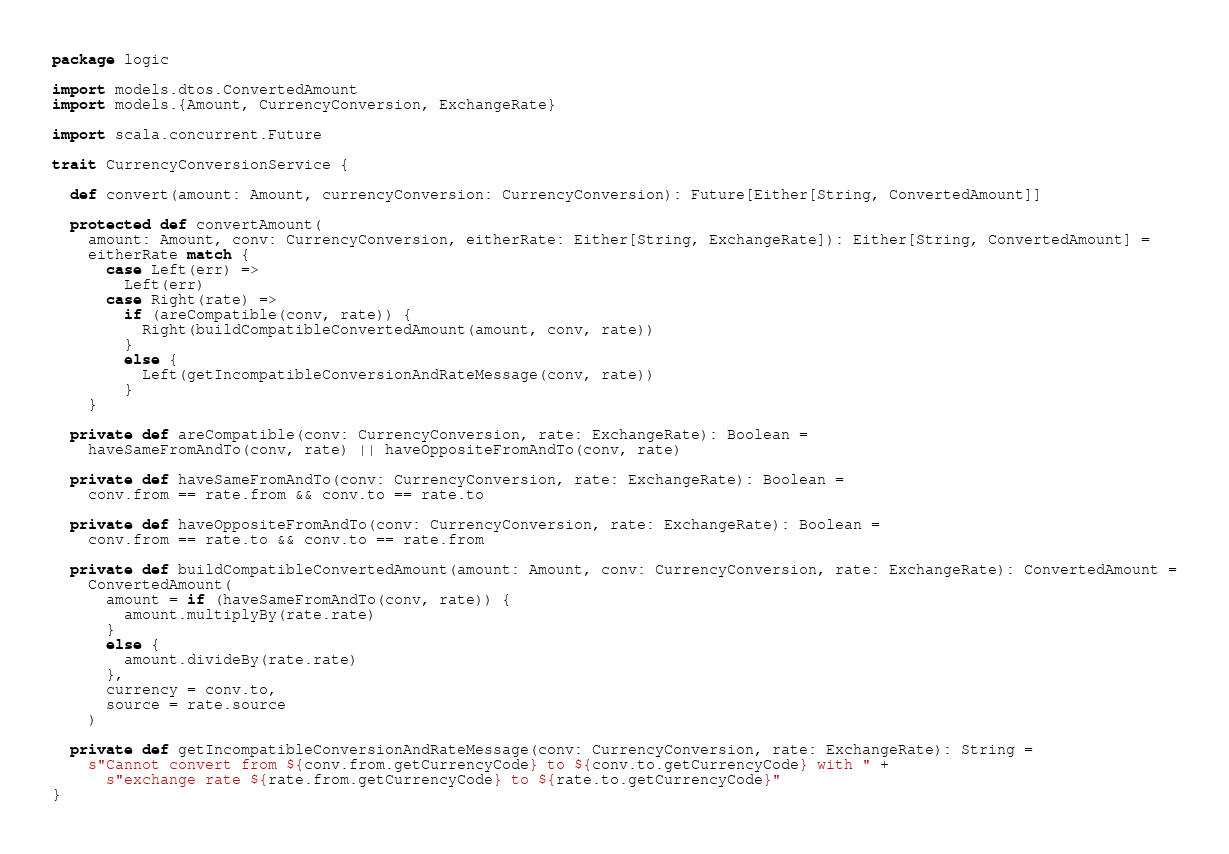Convert code to text. <code><loc_0><loc_0><loc_500><loc_500><_Scala_>package logic

import models.dtos.ConvertedAmount
import models.{Amount, CurrencyConversion, ExchangeRate}

import scala.concurrent.Future

trait CurrencyConversionService {

  def convert(amount: Amount, currencyConversion: CurrencyConversion): Future[Either[String, ConvertedAmount]]

  protected def convertAmount(
    amount: Amount, conv: CurrencyConversion, eitherRate: Either[String, ExchangeRate]): Either[String, ConvertedAmount] =
    eitherRate match {
      case Left(err) =>
        Left(err)
      case Right(rate) =>
        if (areCompatible(conv, rate)) {
          Right(buildCompatibleConvertedAmount(amount, conv, rate))
        }
        else {
          Left(getIncompatibleConversionAndRateMessage(conv, rate))
        }
    }

  private def areCompatible(conv: CurrencyConversion, rate: ExchangeRate): Boolean =
    haveSameFromAndTo(conv, rate) || haveOppositeFromAndTo(conv, rate)

  private def haveSameFromAndTo(conv: CurrencyConversion, rate: ExchangeRate): Boolean =
    conv.from == rate.from && conv.to == rate.to

  private def haveOppositeFromAndTo(conv: CurrencyConversion, rate: ExchangeRate): Boolean =
    conv.from == rate.to && conv.to == rate.from

  private def buildCompatibleConvertedAmount(amount: Amount, conv: CurrencyConversion, rate: ExchangeRate): ConvertedAmount =
    ConvertedAmount(
      amount = if (haveSameFromAndTo(conv, rate)) {
        amount.multiplyBy(rate.rate)
      }
      else {
        amount.divideBy(rate.rate)
      },
      currency = conv.to,
      source = rate.source
    )

  private def getIncompatibleConversionAndRateMessage(conv: CurrencyConversion, rate: ExchangeRate): String =
    s"Cannot convert from ${conv.from.getCurrencyCode} to ${conv.to.getCurrencyCode} with " +
      s"exchange rate ${rate.from.getCurrencyCode} to ${rate.to.getCurrencyCode}"
}
</code> 